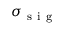Convert formula to latex. <formula><loc_0><loc_0><loc_500><loc_500>\sigma _ { s i g }</formula> 